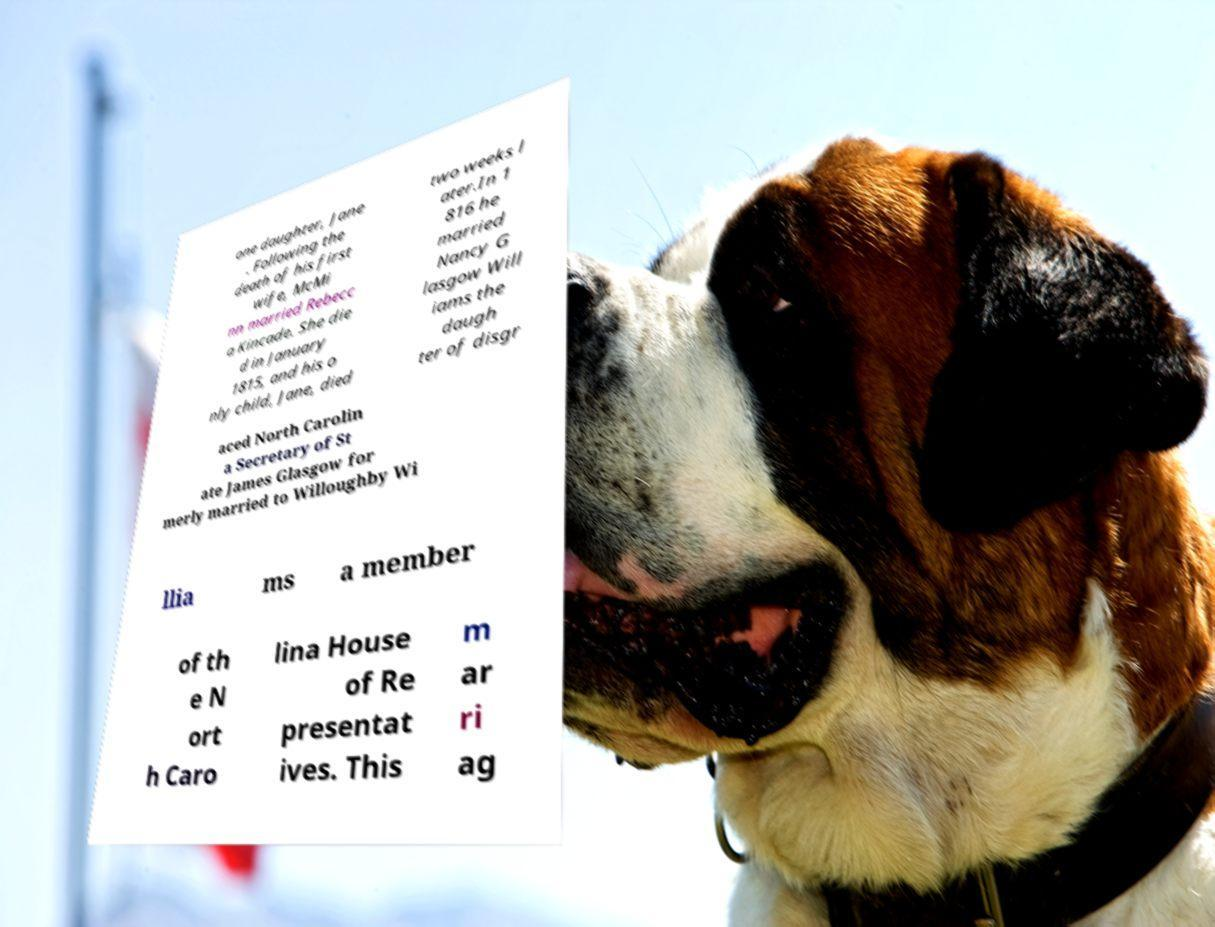Can you accurately transcribe the text from the provided image for me? one daughter, Jane . Following the death of his first wife, McMi nn married Rebecc a Kincade. She die d in January 1815, and his o nly child, Jane, died two weeks l ater.In 1 816 he married Nancy G lasgow Will iams the daugh ter of disgr aced North Carolin a Secretary of St ate James Glasgow for merly married to Willoughby Wi llia ms a member of th e N ort h Caro lina House of Re presentat ives. This m ar ri ag 